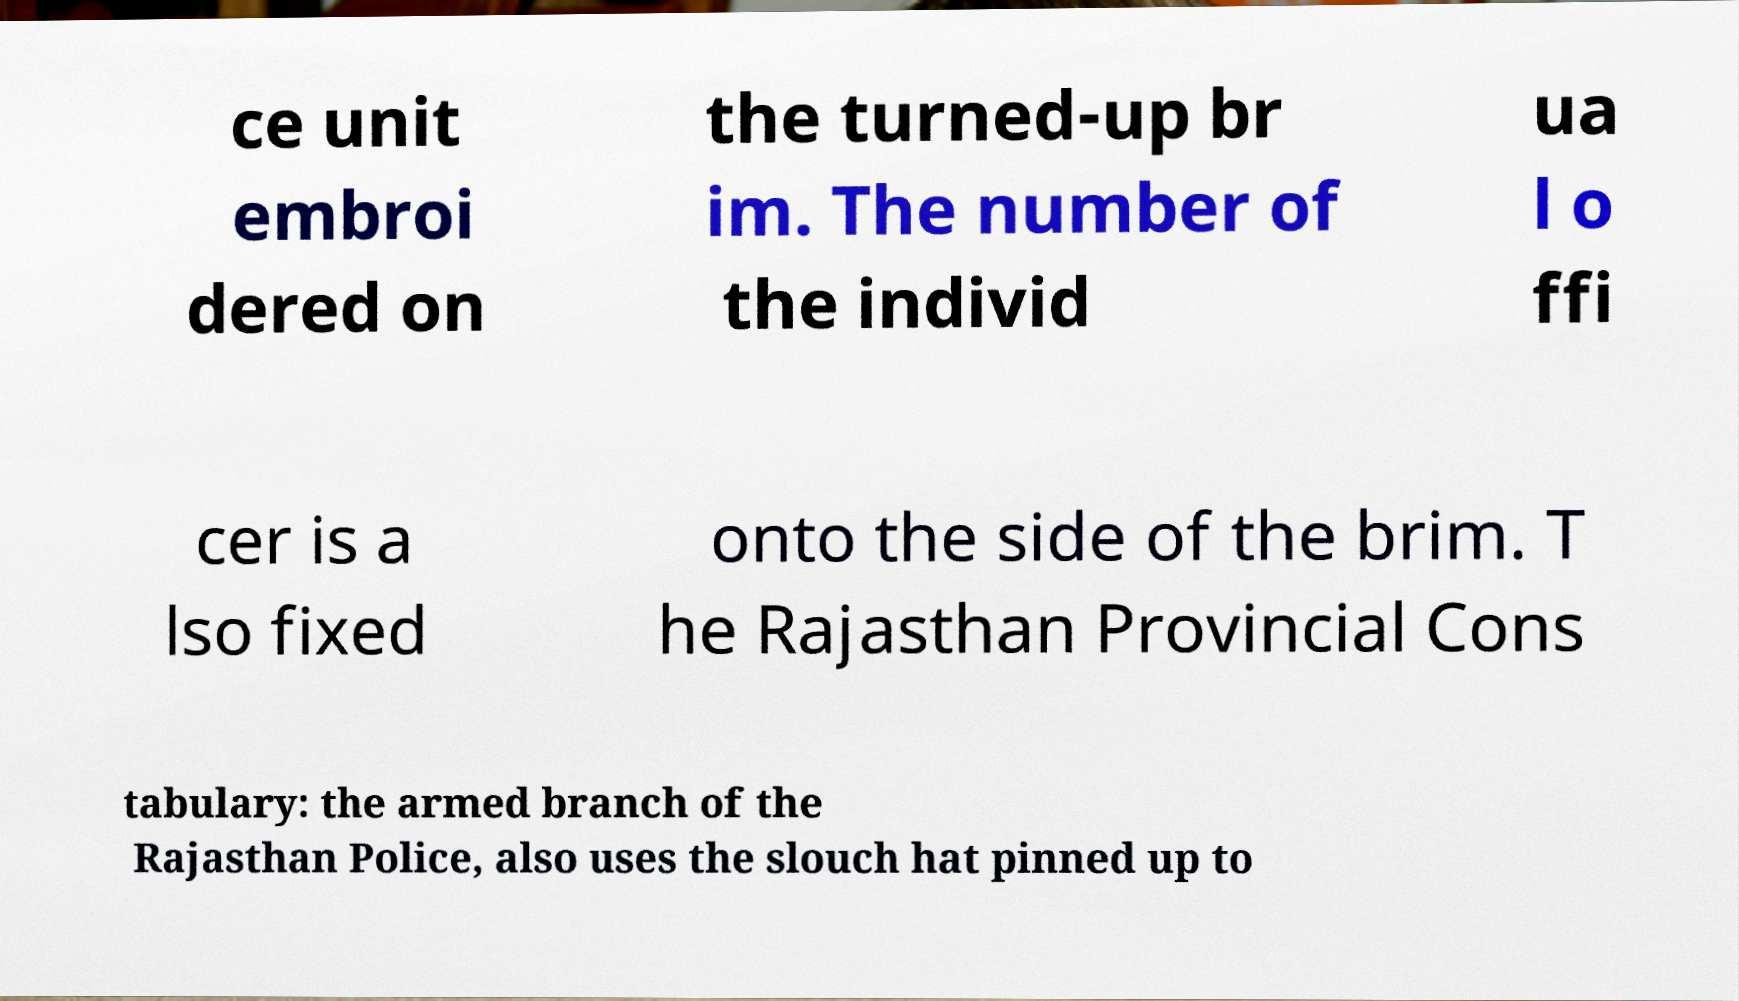There's text embedded in this image that I need extracted. Can you transcribe it verbatim? ce unit embroi dered on the turned-up br im. The number of the individ ua l o ffi cer is a lso fixed onto the side of the brim. T he Rajasthan Provincial Cons tabulary: the armed branch of the Rajasthan Police, also uses the slouch hat pinned up to 